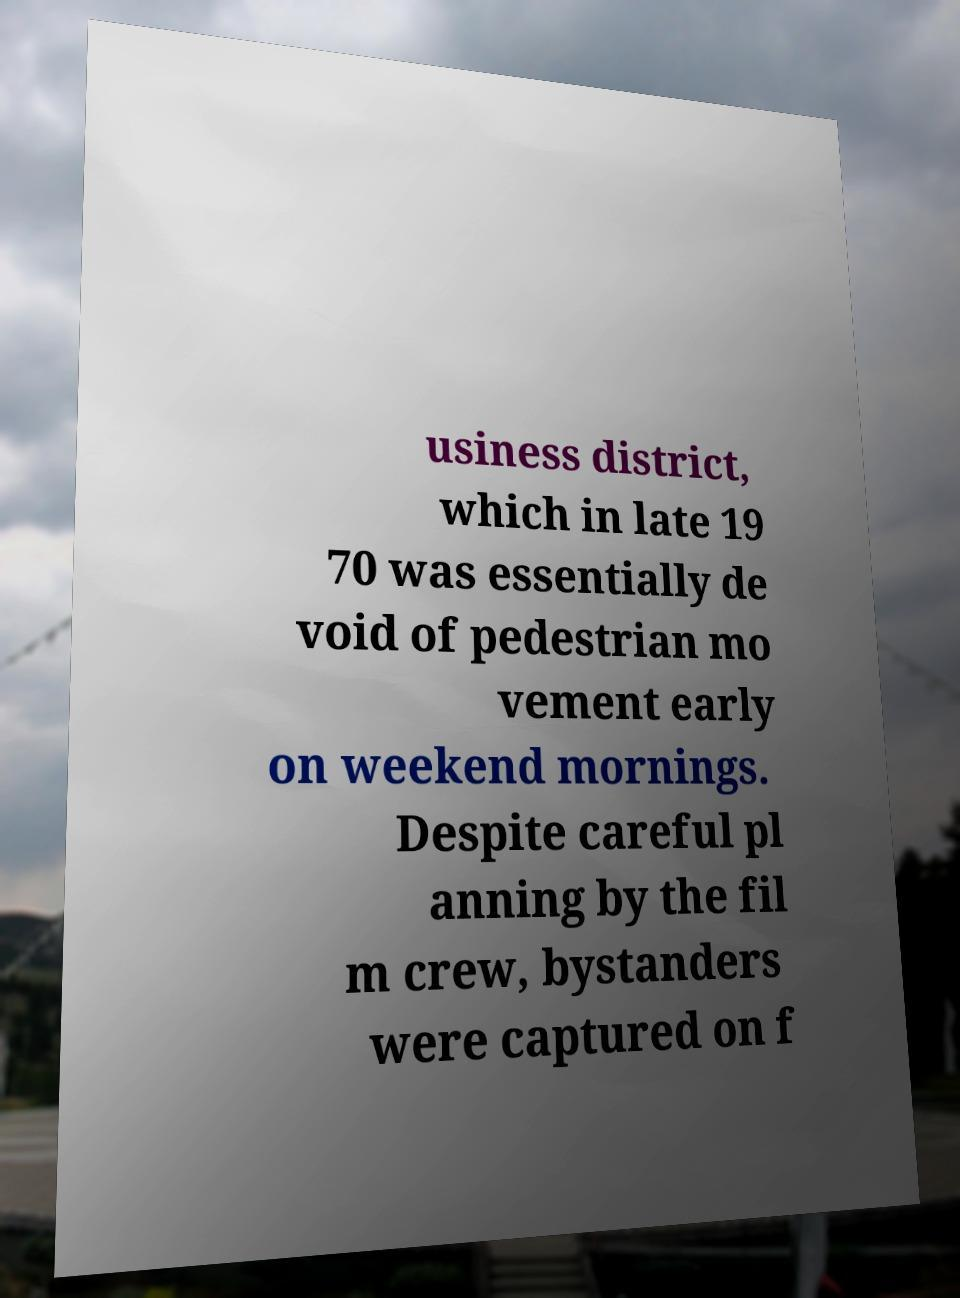For documentation purposes, I need the text within this image transcribed. Could you provide that? usiness district, which in late 19 70 was essentially de void of pedestrian mo vement early on weekend mornings. Despite careful pl anning by the fil m crew, bystanders were captured on f 